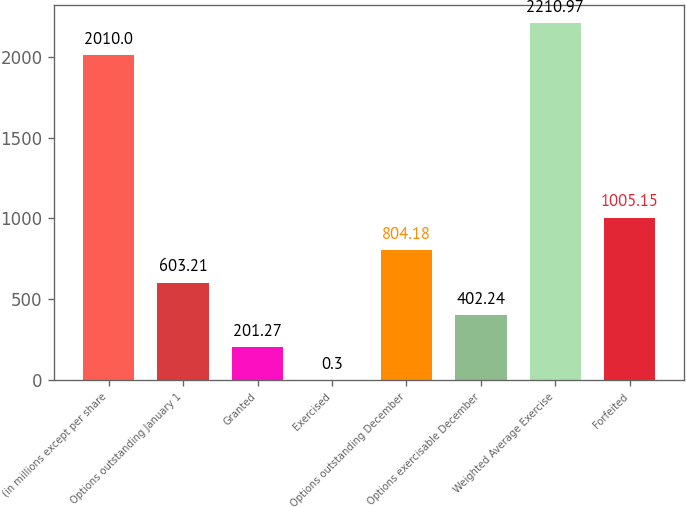Convert chart to OTSL. <chart><loc_0><loc_0><loc_500><loc_500><bar_chart><fcel>(in millions except per share<fcel>Options outstanding January 1<fcel>Granted<fcel>Exercised<fcel>Options outstanding December<fcel>Options exercisable December<fcel>Weighted Average Exercise<fcel>Forfeited<nl><fcel>2010<fcel>603.21<fcel>201.27<fcel>0.3<fcel>804.18<fcel>402.24<fcel>2210.97<fcel>1005.15<nl></chart> 